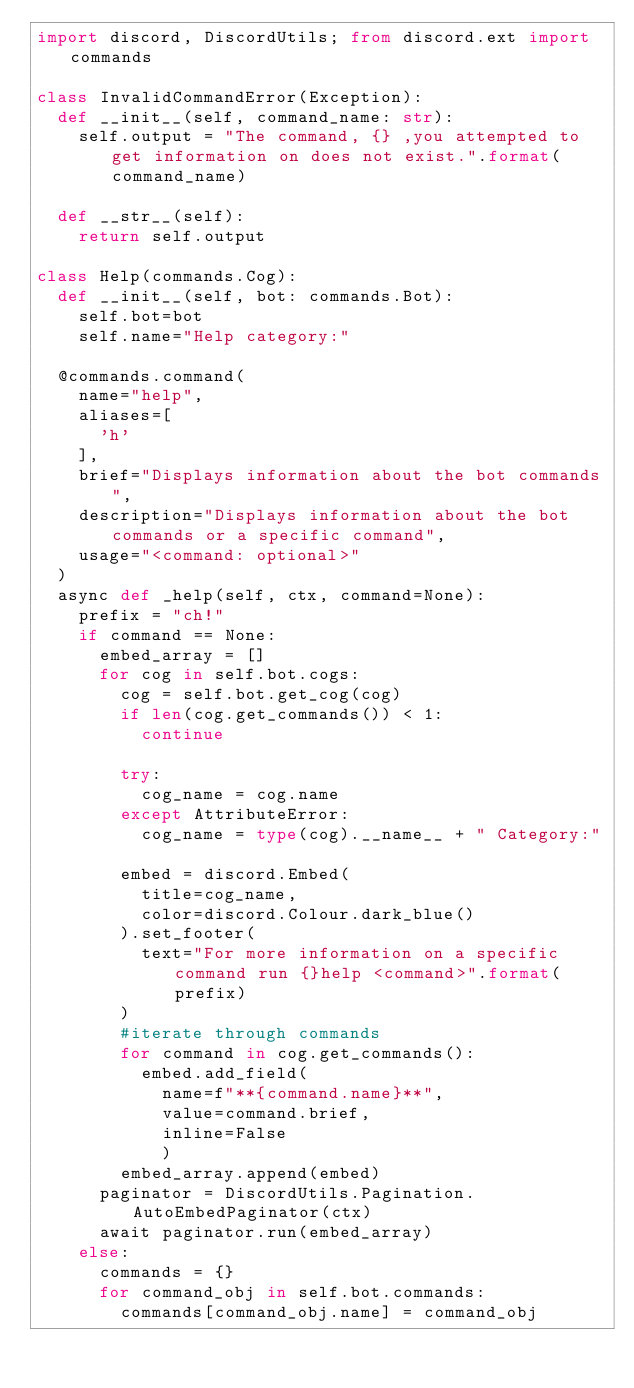Convert code to text. <code><loc_0><loc_0><loc_500><loc_500><_Python_>import discord, DiscordUtils; from discord.ext import commands

class InvalidCommandError(Exception):
  def __init__(self, command_name: str):
    self.output = "The command, {} ,you attempted to get information on does not exist.".format(command_name)

  def __str__(self):
    return self.output

class Help(commands.Cog):
  def __init__(self, bot: commands.Bot):
    self.bot=bot
    self.name="Help category:"

  @commands.command(
    name="help",
    aliases=[
      'h'
    ],
    brief="Displays information about the bot commands",
    description="Displays information about the bot commands or a specific command",
    usage="<command: optional>"
  )
  async def _help(self, ctx, command=None):
    prefix = "ch!"
    if command == None:
      embed_array = [] 
      for cog in self.bot.cogs:
        cog = self.bot.get_cog(cog)
        if len(cog.get_commands()) < 1:
          continue

        try:
          cog_name = cog.name
        except AttributeError:
          cog_name = type(cog).__name__ + " Category:"
        
        embed = discord.Embed(
          title=cog_name,
          color=discord.Colour.dark_blue()
        ).set_footer(
          text="For more information on a specific command run {}help <command>".format(prefix)
        )
        #iterate through commands
        for command in cog.get_commands():
          embed.add_field(
            name=f"**{command.name}**",
            value=command.brief,
            inline=False
            )
        embed_array.append(embed)
      paginator = DiscordUtils.Pagination.AutoEmbedPaginator(ctx)
      await paginator.run(embed_array)
    else:
      commands = {}
      for command_obj in self.bot.commands:
        commands[command_obj.name] = command_obj</code> 